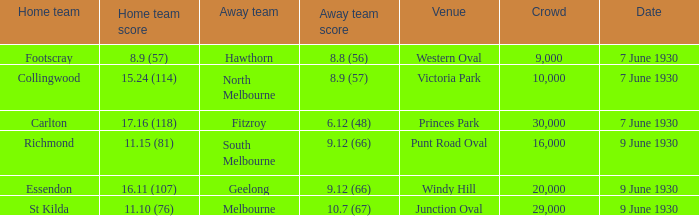Where did the visiting team achieve Victoria Park. 